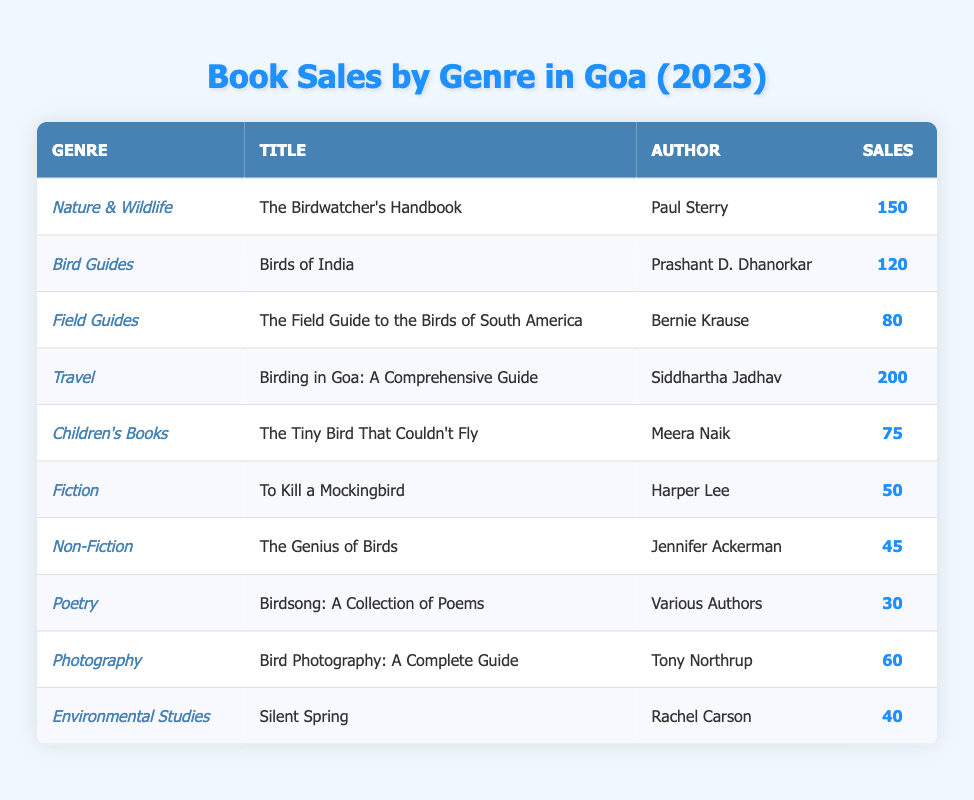What is the total number of sales for books in the Nature & Wildlife genre? The table shows that there is one entry for the Nature & Wildlife genre, which lists "The Birdwatcher's Handbook" with sales of 150. Therefore, the total sales for this genre is simply 150.
Answer: 150 Which book in the Travel genre has the highest sales? The table lists "Birding in Goa: A Comprehensive Guide" in the Travel genre with sales of 200. This is the only entry in the Travel genre, making it the highest.
Answer: Birding in Goa: A Comprehensive Guide What is the total sales for all titles listed under the Bird Guides genre? There is one book in the Bird Guides genre, "Birds of India," with 120 sales. Thus, the total for this genre is 120 sales.
Answer: 120 What is the average sales for books in the Children's genre when combining "The Tiny Bird That Couldn't Fly" with all other genres? There is only one book in the Children's genre, and it has sales of 75. To calculate the average, one needs to consider the overall total sales from all entries: (150 + 120 + 80 + 200 + 75 + 50 + 45 + 30 + 60 + 40) = 900, and there are 10 genres. Therefore, the average is 900/10 = 90.
Answer: 90 Which genre had the least sales amongst the listed entries? By reviewing the sales figures in the table, the lowest value is 30 from the Poetry genre ("Birdsong: A Collection of Poems"), making it the least selling genre.
Answer: Poetry Are there more sales in the Nature & Wildlife genre compared to the Environmental Studies genre? The Nature & Wildlife genre has 150 sales, while the Environmental Studies genre has 40 sales. Thus, the Nature & Wildlife genre has significantly more sales.
Answer: Yes If we combine the sales from the Bird Guides and Field Guides genres, how much total sales do they contribute? The sales for Bird Guides ("Birds of India") is 120 and Field Guides ("The Field Guide to the Birds of South America") is 80. Adding these together gives 120 + 80 = 200.
Answer: 200 What percentage of total sales do the sales from the Fiction genre represent? The sales figure for the Fiction genre ("To Kill a Mockingbird") is 50. Total sales across all genres is 900. The percentage is calculated as (50/900) * 100 = 5.56%.
Answer: 5.56% How many books in the table have sales greater than 100? The books with sales greater than 100 are "The Birdwatcher's Handbook," "Birding in Goa: A Comprehensive Guide," and "Birds of India." This brings the total count to 3 books.
Answer: 3 If we were to list all genres with sales under 100, how many would there be? The genres with sales under 100 are: Field Guides (80), Children's Books (75), Fiction (50), Non-Fiction (45), Poetry (30), Photography (60), and Environmental Studies (40). Counting these entries gives a total of 7 genres.
Answer: 7 